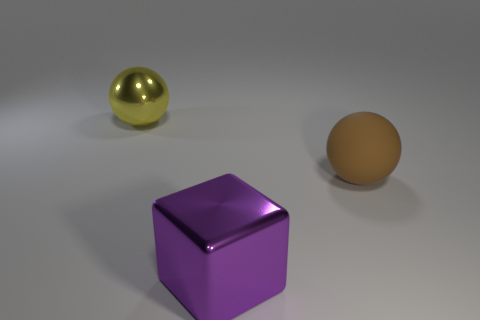Is there anything else that is made of the same material as the brown thing?
Provide a short and direct response. No. There is a brown thing that is the same size as the purple object; what is it made of?
Give a very brief answer. Rubber. There is a object that is on the left side of the purple metal thing; how big is it?
Ensure brevity in your answer.  Large. Does the metallic thing that is in front of the large brown thing have the same size as the matte sphere that is behind the purple metallic object?
Ensure brevity in your answer.  Yes. What number of spheres have the same material as the purple object?
Make the answer very short. 1. What is the color of the large metallic ball?
Provide a short and direct response. Yellow. Are there any rubber objects left of the large brown ball?
Offer a very short reply. No. Is the large metallic sphere the same color as the big matte object?
Make the answer very short. No. There is a metal thing that is in front of the big yellow sphere that is left of the purple metal block; how big is it?
Ensure brevity in your answer.  Large. What is the shape of the brown rubber thing?
Provide a short and direct response. Sphere. 